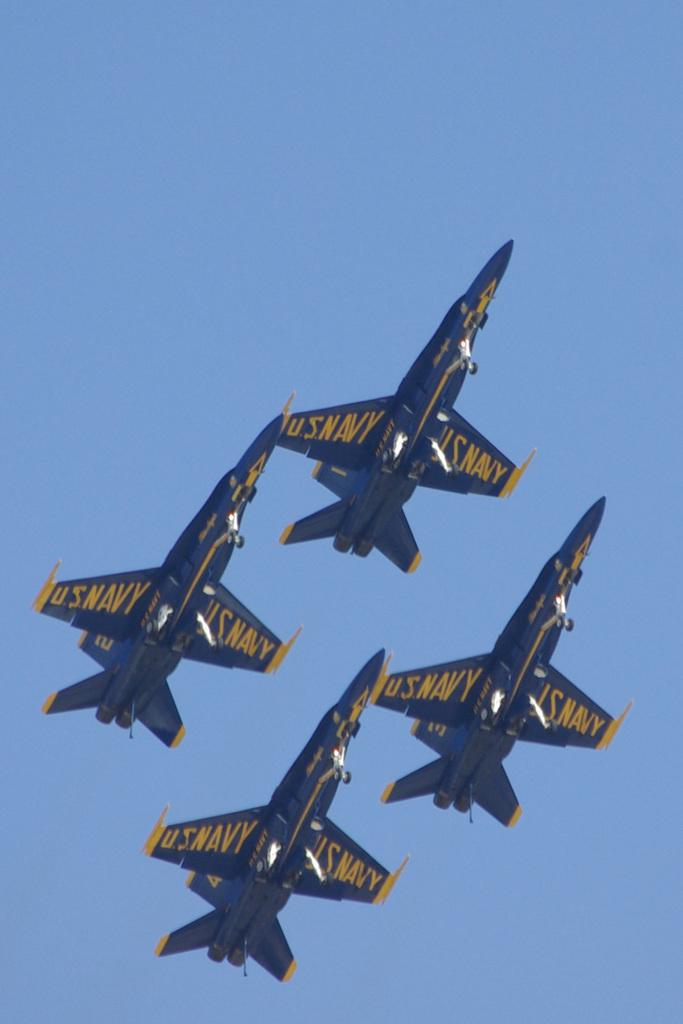<image>
Give a short and clear explanation of the subsequent image. Four blue and yellow U.S. Navy planes fly in formation. 